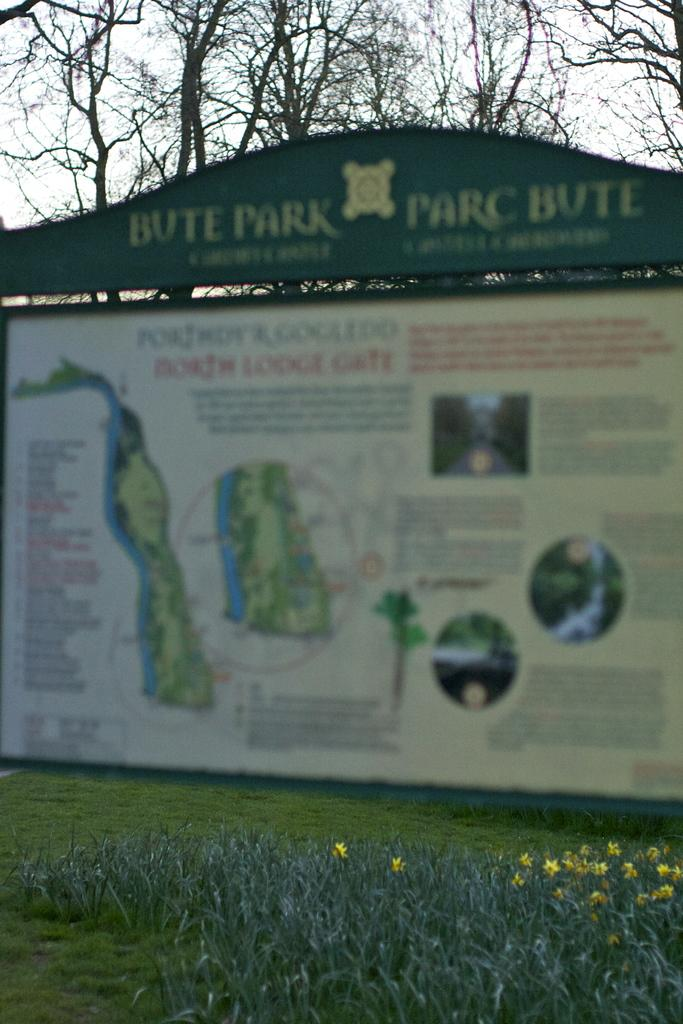What is the main object in the image? There is a board in the image. What is on the board? There are pictures and text on the board. What type of vegetation is visible in the image? There is grass on the wall and trees in the image. What can be seen in the background of the image? The sky is visible in the image. How many bikes are parked next to the board in the image? There are no bikes present in the image. What type of bulb is used to light up the board in the image? There is no bulb present in the image; the board is not illuminated. 